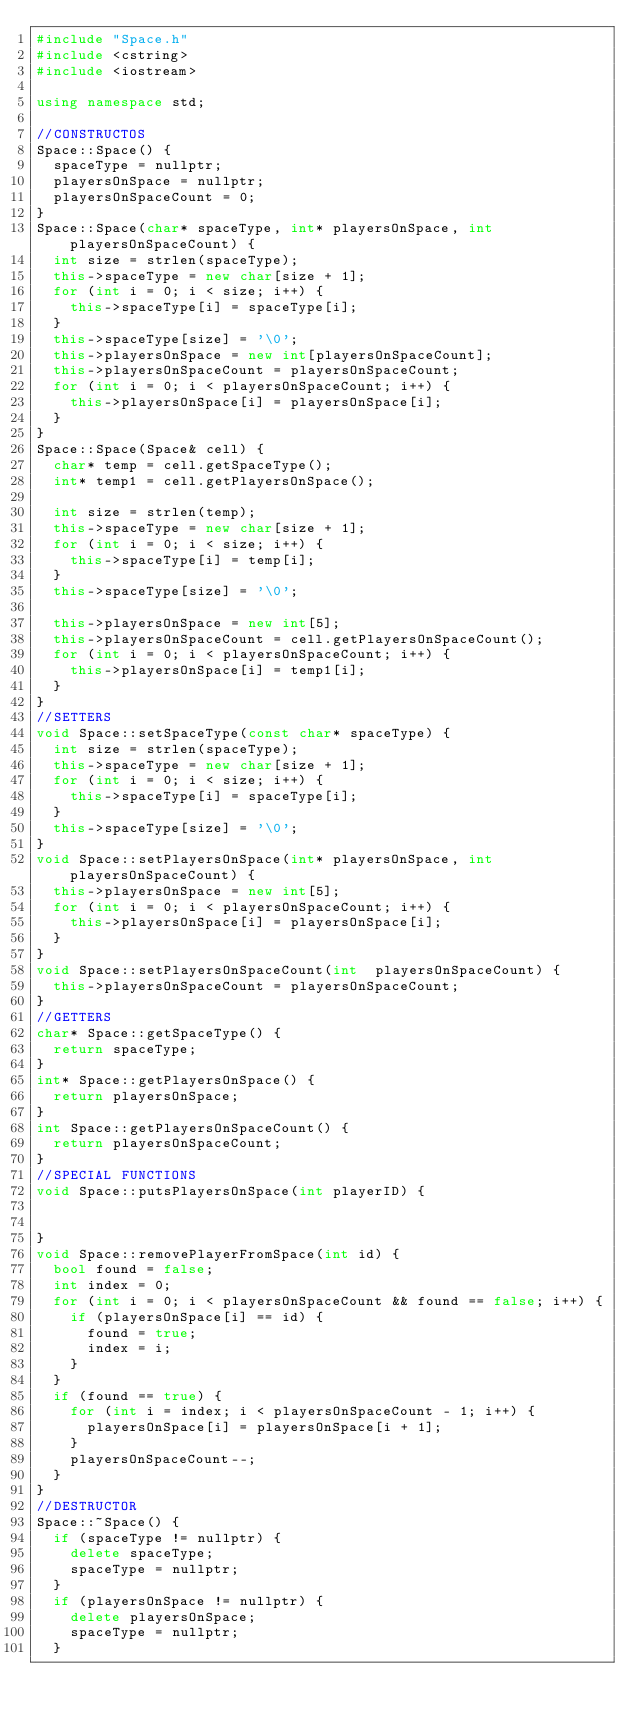Convert code to text. <code><loc_0><loc_0><loc_500><loc_500><_C++_>#include "Space.h"
#include <cstring>
#include <iostream>

using namespace std;

//CONSTRUCTOS
Space::Space() {
	spaceType = nullptr;
	playersOnSpace = nullptr;
	playersOnSpaceCount = 0;
}
Space::Space(char* spaceType, int* playersOnSpace, int playersOnSpaceCount) {
	int size = strlen(spaceType);
	this->spaceType = new char[size + 1];
	for (int i = 0; i < size; i++) {
		this->spaceType[i] = spaceType[i];
	}
	this->spaceType[size] = '\0';
	this->playersOnSpace = new int[playersOnSpaceCount];
	this->playersOnSpaceCount = playersOnSpaceCount;
	for (int i = 0; i < playersOnSpaceCount; i++) {
		this->playersOnSpace[i] = playersOnSpace[i];
	}
}
Space::Space(Space& cell) {
	char* temp = cell.getSpaceType();
	int* temp1 = cell.getPlayersOnSpace();

	int size = strlen(temp);
	this->spaceType = new char[size + 1];
	for (int i = 0; i < size; i++) {
		this->spaceType[i] = temp[i];
	}
	this->spaceType[size] = '\0';

	this->playersOnSpace = new int[5];
	this->playersOnSpaceCount = cell.getPlayersOnSpaceCount();
	for (int i = 0; i < playersOnSpaceCount; i++) {
		this->playersOnSpace[i] = temp1[i];
	}
}
//SETTERS
void Space::setSpaceType(const char* spaceType) {
	int size = strlen(spaceType);
	this->spaceType = new char[size + 1];
	for (int i = 0; i < size; i++) {
		this->spaceType[i] = spaceType[i];
	}
	this->spaceType[size] = '\0';
}
void Space::setPlayersOnSpace(int* playersOnSpace, int playersOnSpaceCount) {
	this->playersOnSpace = new int[5];
	for (int i = 0; i < playersOnSpaceCount; i++) {
		this->playersOnSpace[i] = playersOnSpace[i];
	}
}
void Space::setPlayersOnSpaceCount(int  playersOnSpaceCount) {
	this->playersOnSpaceCount = playersOnSpaceCount;
}
//GETTERS
char* Space::getSpaceType() {
	return spaceType;
}
int* Space::getPlayersOnSpace() {
	return playersOnSpace;
}
int Space::getPlayersOnSpaceCount() {
	return playersOnSpaceCount;
}
//SPECIAL FUNCTIONS
void Space::putsPlayersOnSpace(int playerID) {


}
void Space::removePlayerFromSpace(int id) {
	bool found = false;
	int index = 0;
	for (int i = 0; i < playersOnSpaceCount && found == false; i++) {
		if (playersOnSpace[i] == id) {
			found = true;
			index = i;
		}
	}
	if (found == true) {
		for (int i = index; i < playersOnSpaceCount - 1; i++) {
			playersOnSpace[i] = playersOnSpace[i + 1];
		}
		playersOnSpaceCount--;
	}
}
//DESTRUCTOR
Space::~Space() {
	if (spaceType != nullptr) {
		delete spaceType;
		spaceType = nullptr;
	}
	if (playersOnSpace != nullptr) {
		delete playersOnSpace;
		spaceType = nullptr;
	}</code> 